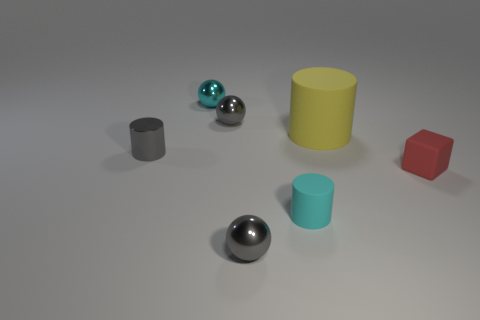Add 2 tiny shiny things. How many objects exist? 9 Subtract all gray metal spheres. How many spheres are left? 1 Subtract all brown cylinders. How many gray balls are left? 2 Subtract 1 cylinders. How many cylinders are left? 2 Subtract all cubes. How many objects are left? 6 Subtract all blue spheres. Subtract all cyan blocks. How many spheres are left? 3 Add 2 small cyan metal things. How many small cyan metal things exist? 3 Subtract 0 blue blocks. How many objects are left? 7 Subtract all small green cylinders. Subtract all cylinders. How many objects are left? 4 Add 5 tiny gray shiny objects. How many tiny gray shiny objects are left? 8 